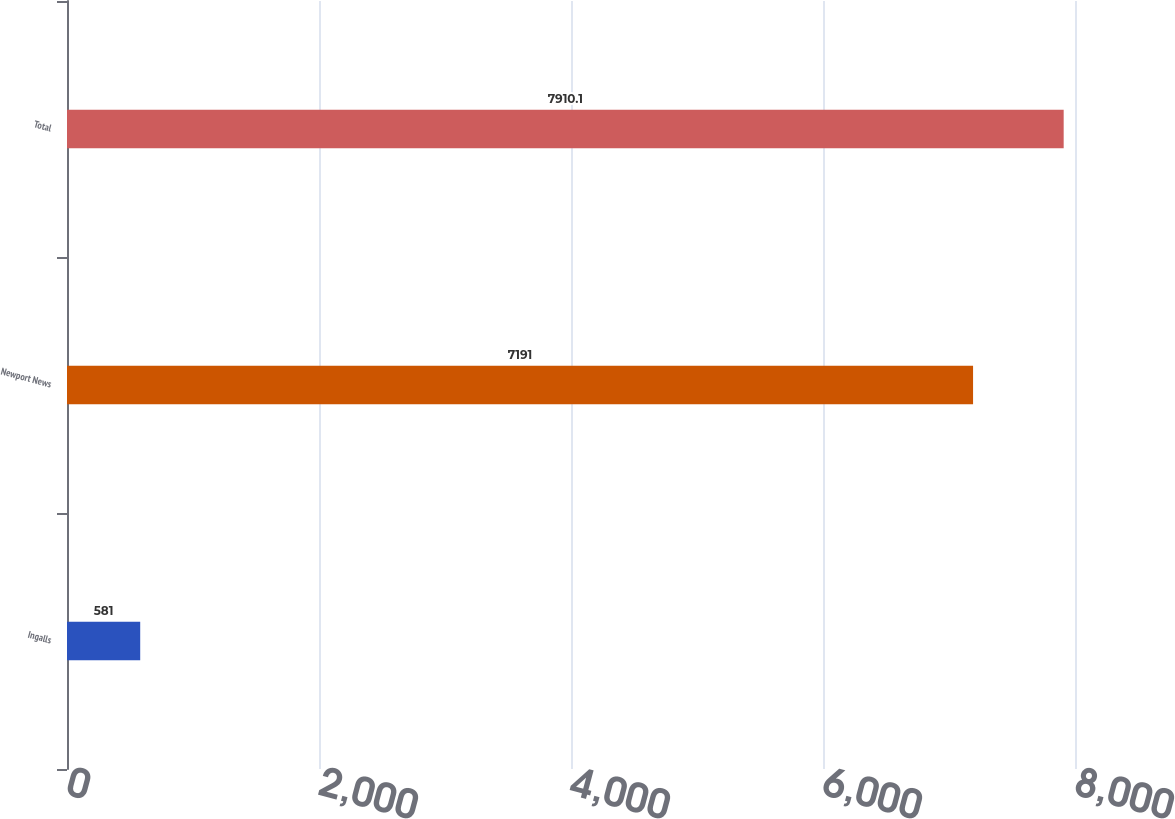<chart> <loc_0><loc_0><loc_500><loc_500><bar_chart><fcel>Ingalls<fcel>Newport News<fcel>Total<nl><fcel>581<fcel>7191<fcel>7910.1<nl></chart> 